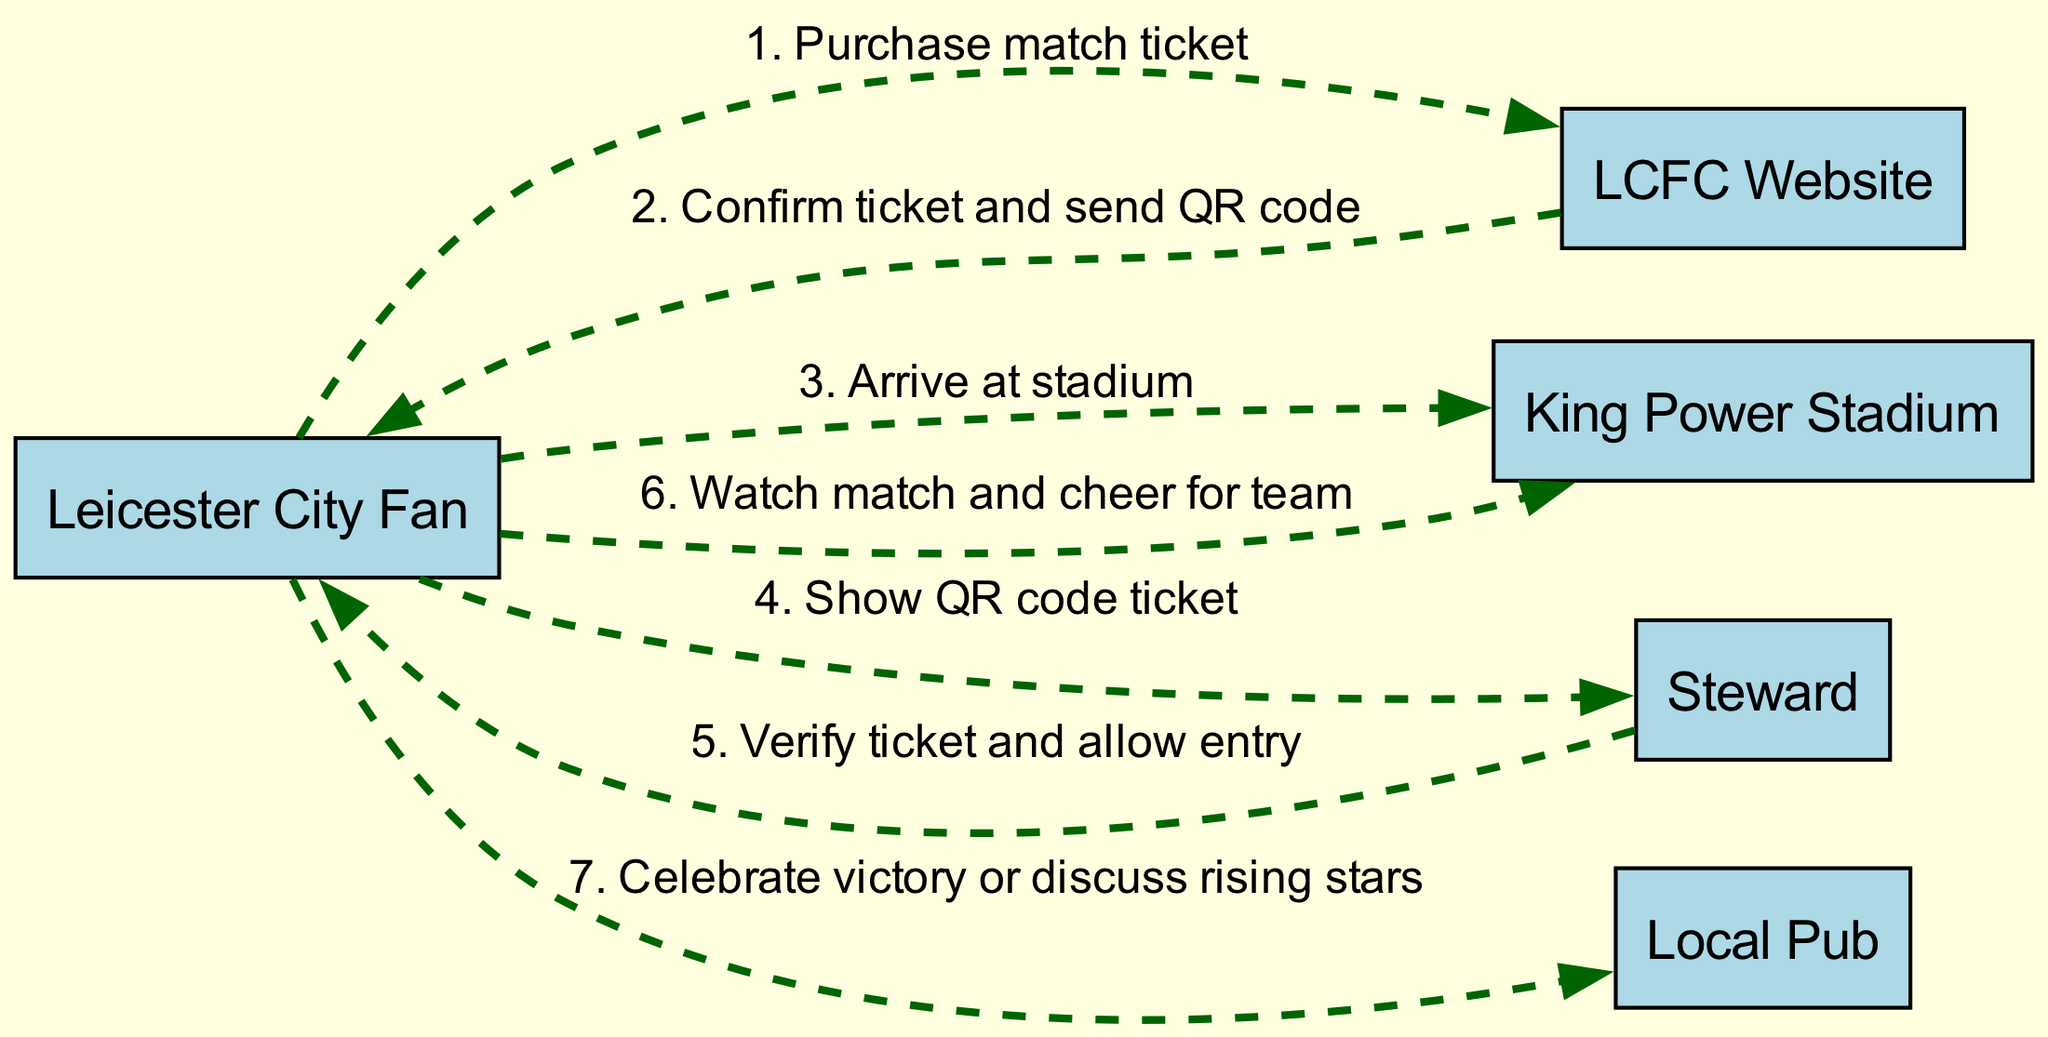What is the first action taken by the Leicester City Fan? The first action in the sequence involves the Leicester City Fan purchasing a match ticket through the LCFC Website.
Answer: Purchase match ticket How many actors are present in the diagram? There are five distinct actors mentioned in the diagram: Leicester City Fan, LCFC Website, King Power Stadium, Steward, and Local Pub.
Answer: Five What action is performed just before watching the match? Before watching the match, the Leicester City Fan shows their QR code ticket to the Steward.
Answer: Show QR code ticket Which actor confirms the ticket purchase? The LCFC Website is responsible for confirming the ticket purchase and sending a QR code to the Leicester City Fan.
Answer: LCFC Website What happens after the Leicester City Fan arrives at the stadium? After arriving at the stadium, the Leicester City Fan presents their QR code ticket to the Steward for verification.
Answer: Show QR code ticket Which action occurs last in the sequence? The final action in the sequence involves the Leicester City Fan celebrating the victory or discussing rising stars at the Local Pub.
Answer: Celebrate victory or discuss rising stars What is the relationship between the LCFC Website and the Leicester City Fan? The relationship consists of an action where the LCFC Website confirms the ticket purchase and sends a QR code to the Leicester City Fan.
Answer: Confirmation of ticket and sending QR code What is the main purpose of showing the QR code ticket? The main purpose of showing the QR code ticket is to allow the Steward to verify the ticket and grant entry to the stadium.
Answer: Verify ticket and allow entry Which two locations are involved in the celebration after the match? The two locations involved in the celebration after the match are the King Power Stadium and the Local Pub.
Answer: King Power Stadium and Local Pub 